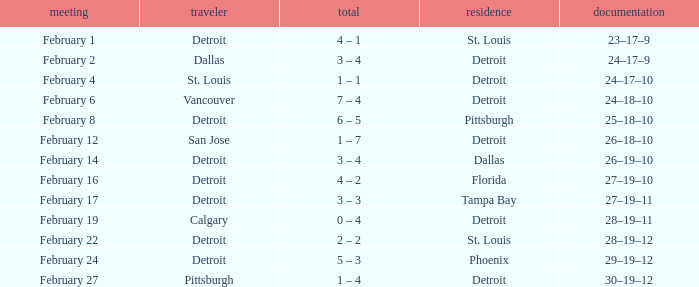Parse the table in full. {'header': ['meeting', 'traveler', 'total', 'residence', 'documentation'], 'rows': [['February 1', 'Detroit', '4 – 1', 'St. Louis', '23–17–9'], ['February 2', 'Dallas', '3 – 4', 'Detroit', '24–17–9'], ['February 4', 'St. Louis', '1 – 1', 'Detroit', '24–17–10'], ['February 6', 'Vancouver', '7 – 4', 'Detroit', '24–18–10'], ['February 8', 'Detroit', '6 – 5', 'Pittsburgh', '25–18–10'], ['February 12', 'San Jose', '1 – 7', 'Detroit', '26–18–10'], ['February 14', 'Detroit', '3 – 4', 'Dallas', '26–19–10'], ['February 16', 'Detroit', '4 – 2', 'Florida', '27–19–10'], ['February 17', 'Detroit', '3 – 3', 'Tampa Bay', '27–19–11'], ['February 19', 'Calgary', '0 – 4', 'Detroit', '28–19–11'], ['February 22', 'Detroit', '2 – 2', 'St. Louis', '28–19–12'], ['February 24', 'Detroit', '5 – 3', 'Phoenix', '29–19–12'], ['February 27', 'Pittsburgh', '1 – 4', 'Detroit', '30–19–12']]} What was their record when they were at Pittsburgh? 25–18–10. 